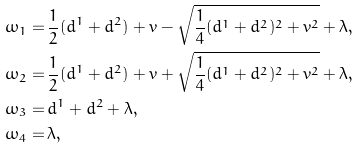<formula> <loc_0><loc_0><loc_500><loc_500>\omega _ { 1 } = \, & \frac { 1 } { 2 } ( d ^ { 1 } + d ^ { 2 } ) + v - \sqrt { \frac { 1 } { 4 } ( d ^ { 1 } + d ^ { 2 } ) ^ { 2 } + v ^ { 2 } } + \lambda , \\ \omega _ { 2 } = \, & \frac { 1 } { 2 } ( d ^ { 1 } + d ^ { 2 } ) + v + \sqrt { \frac { 1 } { 4 } ( d ^ { 1 } + d ^ { 2 } ) ^ { 2 } + v ^ { 2 } } + \lambda , \\ \omega _ { 3 } = \, & d ^ { 1 } + d ^ { 2 } + \lambda , \\ \omega _ { 4 } = \, & \lambda ,</formula> 